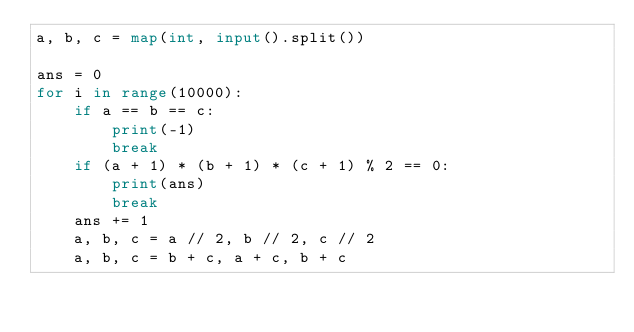<code> <loc_0><loc_0><loc_500><loc_500><_Python_>a, b, c = map(int, input().split())

ans = 0
for i in range(10000):
    if a == b == c:
        print(-1)
        break
    if (a + 1) * (b + 1) * (c + 1) % 2 == 0:
        print(ans)
        break
    ans += 1
    a, b, c = a // 2, b // 2, c // 2
    a, b, c = b + c, a + c, b + c</code> 